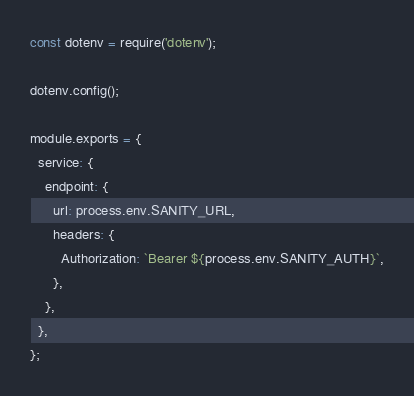Convert code to text. <code><loc_0><loc_0><loc_500><loc_500><_JavaScript_>const dotenv = require('dotenv');

dotenv.config();

module.exports = {
  service: {
    endpoint: {
      url: process.env.SANITY_URL,
      headers: {
        Authorization: `Bearer ${process.env.SANITY_AUTH}`,
      },
    },
  },
};
</code> 